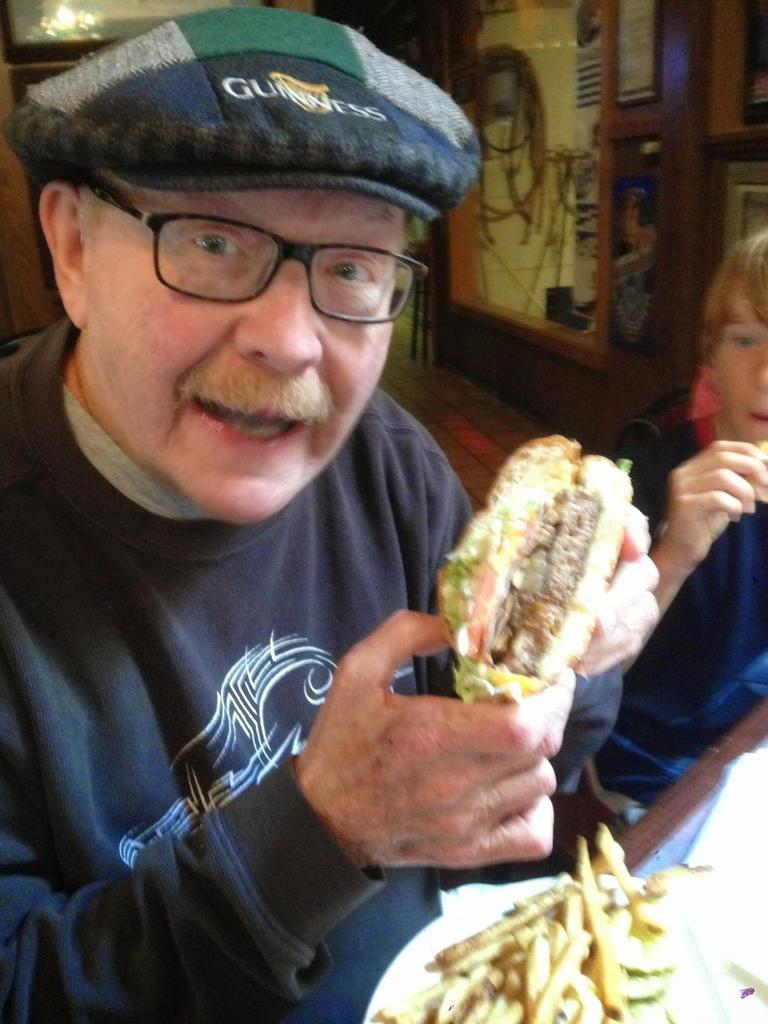What is the person holding in the image? The person is holding a burger in the image. What food item is visible on a plate in the image? There is a plate of french fries in the image. Who is beside the person holding the burger? There is a boy beside the person holding the burger. What can be seen in the background of the image? There is a wooden wall in the background of the image. What type of cattle can be seen grazing in the cemetery in the image? There is no cemetery or cattle present in the image. 